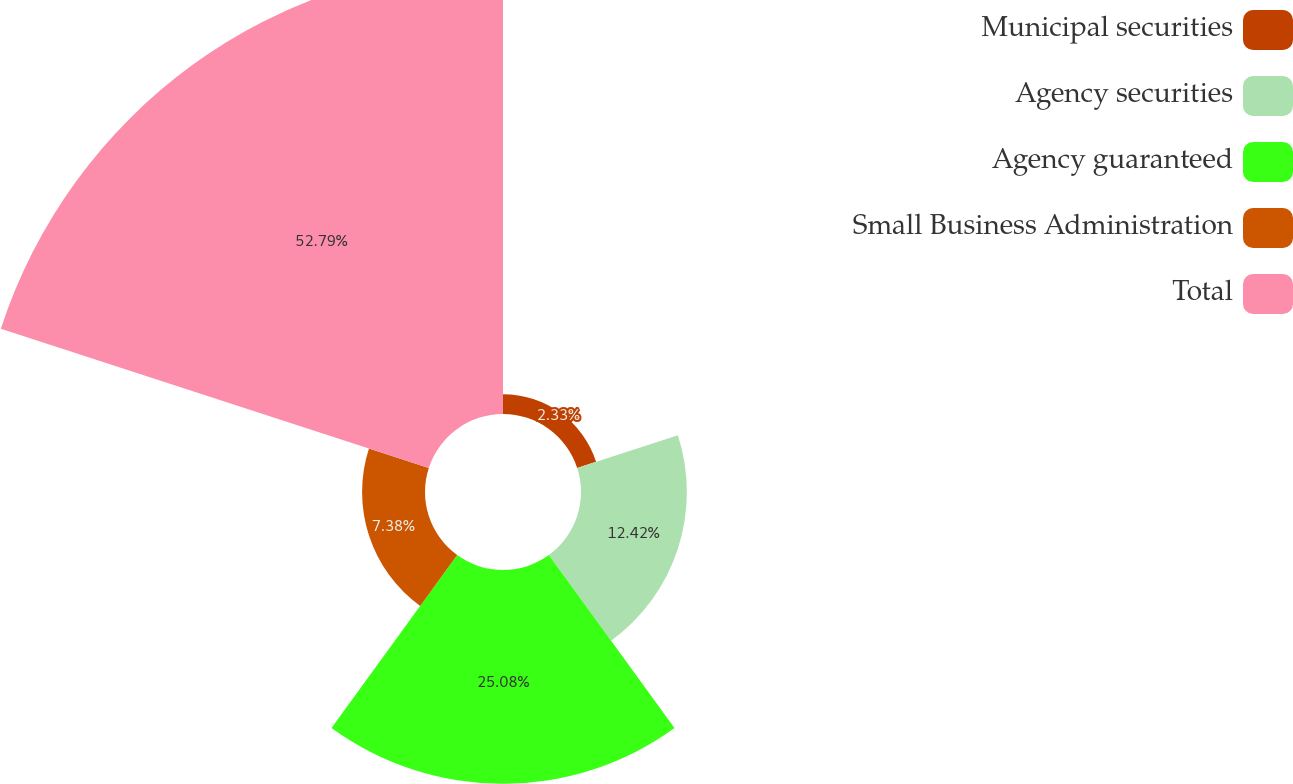Convert chart to OTSL. <chart><loc_0><loc_0><loc_500><loc_500><pie_chart><fcel>Municipal securities<fcel>Agency securities<fcel>Agency guaranteed<fcel>Small Business Administration<fcel>Total<nl><fcel>2.33%<fcel>12.42%<fcel>25.08%<fcel>7.38%<fcel>52.79%<nl></chart> 